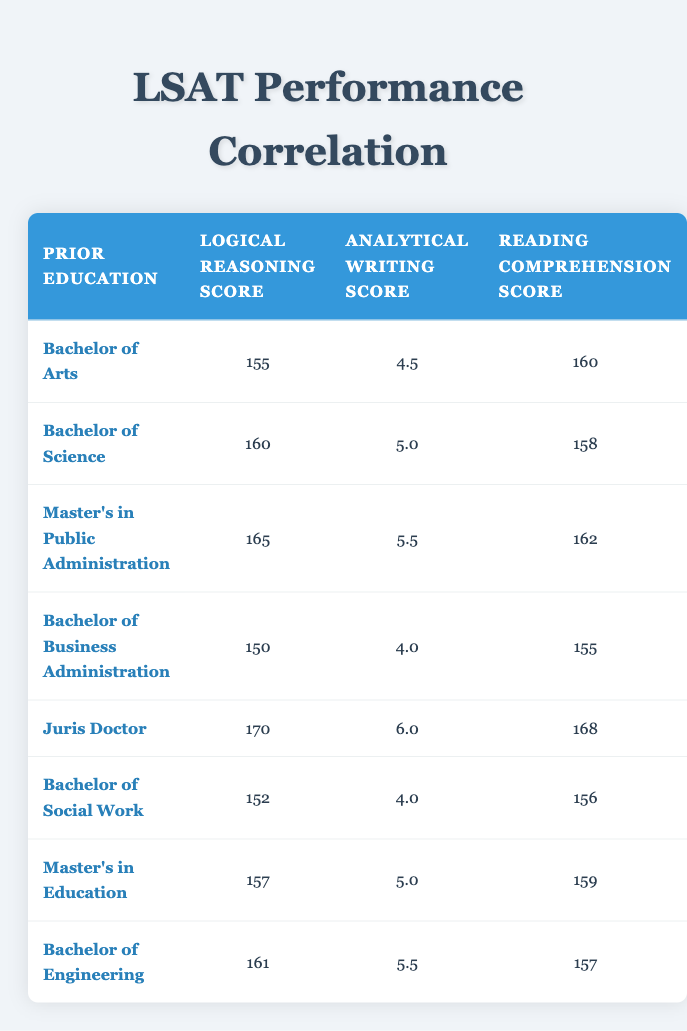What is the highest logical reasoning score listed in the table? The highest logical reasoning score can be found by checking each score in the "Logical Reasoning Score" column. The scores are 155, 160, 165, 150, 170, 152, 157, and 161. The highest value among these is 170, corresponding to the Juris Doctor education level.
Answer: 170 What is the average analytical writing score for students with a Bachelor's degree? The Bachelor's degrees are in Arts, Science, Business Administration, Social Work, and Engineering. Their analytical writing scores are 4.5, 5.0, 4.0, 4.0, and 5.5, respectively. To find the average, we sum these scores: (4.5 + 5.0 + 4.0 + 4.0 + 5.5) = 23.0, then divide by the number of degrees (5), resulting in 23.0 / 5 = 4.6.
Answer: 4.6 Is it true that all students with a Master's degree scored above 160 in logical reasoning? We have two Master's degrees: Master's in Public Administration (165) and Master's in Education (157). The Master’s in Education scored below 160, so the statement is false.
Answer: No Which prior education has the lowest reading comprehension score? The reading comprehension scores listed are 160, 158, 162, 155, 168, 156, 159, and 157. The lowest score among these is 155, which corresponds to the Bachelor of Business Administration.
Answer: Bachelor of Business Administration What is the difference in reading comprehension scores between the highest and lowest scoring degrees? The highest reading comprehension score is 168 (Juris Doctor) and the lowest is 155 (Bachelor of Business Administration). The difference is calculated as 168 - 155 = 13.
Answer: 13 Which degree has the highest analytical writing score, and what is that score? The scores for analytical writing are 4.5, 5.0, 5.5, 4.0, 6.0, 4.0, 5.0, and 5.5. The highest score is 6.0, which is associated with the Juris Doctor degree.
Answer: Juris Doctor, 6.0 What is the total score of logical reasoning for students with a Bachelor of Science and a Master’s in Public Administration? The logical reasoning scores for Bachelor of Science (160) and Master's in Public Administration (165) need to be summed. The total score is 160 + 165 = 325.
Answer: 325 How many degrees have analytical writing scores that are at least 5.0? The analytical writing scores of 5.0 and higher are from Bachelor of Science (5.0), Master's in Public Administration (5.5), Juris Doctor (6.0), and Bachelor's in Engineering (5.5). This sums to four degrees, meeting the criteria.
Answer: 4 